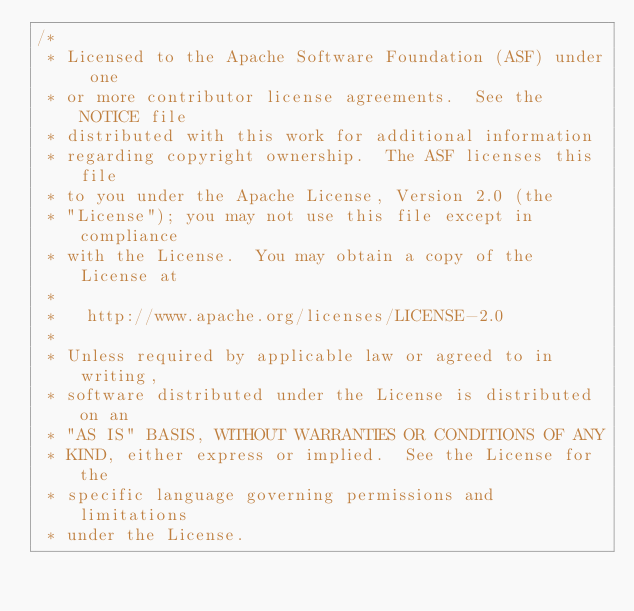<code> <loc_0><loc_0><loc_500><loc_500><_Cuda_>/*
 * Licensed to the Apache Software Foundation (ASF) under one
 * or more contributor license agreements.  See the NOTICE file
 * distributed with this work for additional information
 * regarding copyright ownership.  The ASF licenses this file
 * to you under the Apache License, Version 2.0 (the
 * "License"); you may not use this file except in compliance
 * with the License.  You may obtain a copy of the License at
 *
 *   http://www.apache.org/licenses/LICENSE-2.0
 *
 * Unless required by applicable law or agreed to in writing,
 * software distributed under the License is distributed on an
 * "AS IS" BASIS, WITHOUT WARRANTIES OR CONDITIONS OF ANY
 * KIND, either express or implied.  See the License for the
 * specific language governing permissions and limitations
 * under the License.</code> 